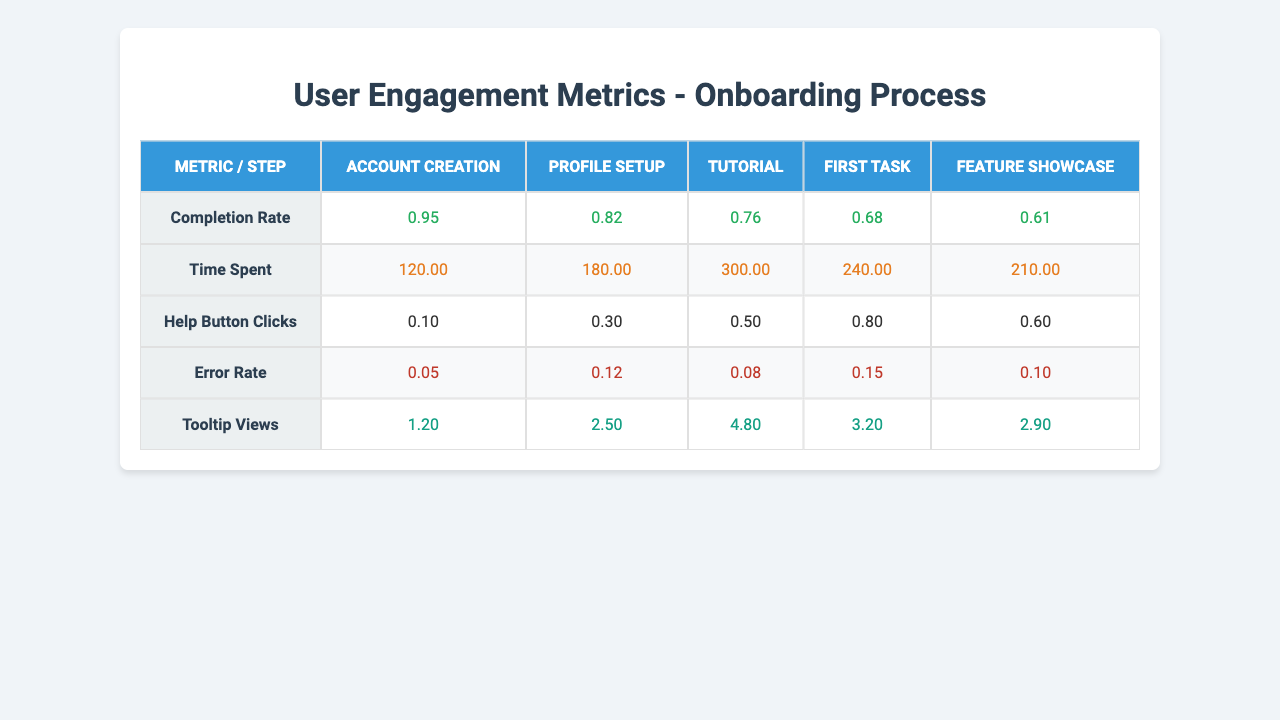What is the completion rate for the Tutorial step? The table shows that the completion rate for the Tutorial step is listed under the "Completion Rate" row and the "Tutorial" column, which equals 0.76.
Answer: 0.76 What is the average time spent across all steps? To find the average time spent, we sum the time spent for each step (120 + 180 + 300 + 240 + 210 = 1050) and divide by the number of steps (5). Thus, the average is 1050 / 5 = 210.
Answer: 210 Which step has the highest Error Rate? Looking at the "Error Rate" row, "First Task" has the highest value at 0.15 compared to the other steps.
Answer: First Task Is the Help Button Clicks for Profile Setup greater than the Help Button Clicks for Account Creation? The Help Button Clicks for Profile Setup is 0.3 and for Account Creation it is 0.1. Since 0.3 is greater than 0.1, the statement is true.
Answer: Yes What is the difference in Tooltip Views between the Feature Showcase and Profile Setup? The Tooltip Views for Feature Showcase is 2.9 and for Profile Setup is 2.5. The difference is calculated as 2.9 - 2.5 = 0.4.
Answer: 0.4 Which step has the lowest Completion Rate? By examining the "Completion Rate" values, we see that the Feature Showcase has the lowest rate at 0.61.
Answer: Feature Showcase What is the total Help Button Clicks across all steps? To find the total, we add the Help Button Clicks for each step (0.1 + 0.3 + 0.5 + 0.8 + 0.6 = 2.3).
Answer: 2.3 Is the Time Spent for the Tutorial longer than the Time Spent for Feature Showcase? The Time Spent for the Tutorial is 300 and for Feature Showcase 210. Since 300 is greater than 210, the statement is true.
Answer: Yes What is the average Completion Rate across all steps? To calculate the average Completion Rate, sum the rates (0.95 + 0.82 + 0.76 + 0.68 + 0.61 = 3.82) and divide by the number of steps (5). Thus, the average is 3.82 / 5 = 0.764.
Answer: 0.764 Which step shows the most tooltip views and how many? The table indicates that the Tutorial has the highest number of Tooltip Views at 4.8.
Answer: Tutorial, 4.8 